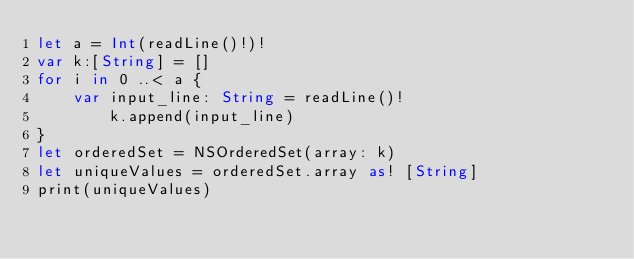Convert code to text. <code><loc_0><loc_0><loc_500><loc_500><_Swift_>let a = Int(readLine()!)!
var k:[String] = []
for i in 0 ..< a {
    var input_line: String = readLine()!
        k.append(input_line)
}
let orderedSet = NSOrderedSet(array: k)
let uniqueValues = orderedSet.array as! [String]
print(uniqueValues) </code> 